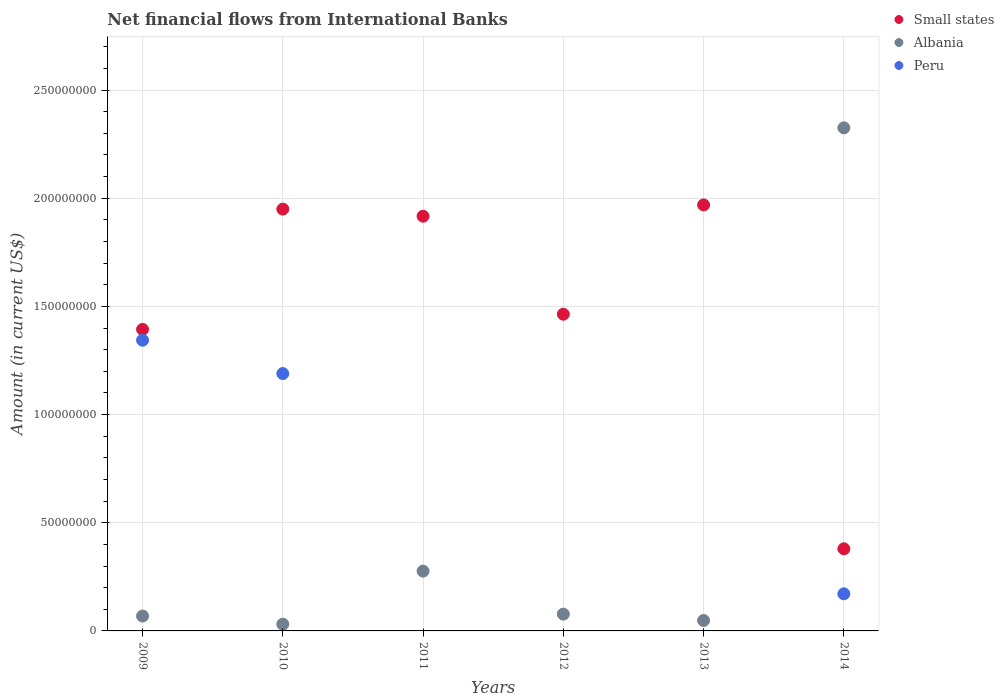How many different coloured dotlines are there?
Offer a terse response. 3. Is the number of dotlines equal to the number of legend labels?
Ensure brevity in your answer.  No. What is the net financial aid flows in Albania in 2014?
Keep it short and to the point. 2.33e+08. Across all years, what is the maximum net financial aid flows in Albania?
Offer a terse response. 2.33e+08. Across all years, what is the minimum net financial aid flows in Small states?
Give a very brief answer. 3.80e+07. In which year was the net financial aid flows in Albania maximum?
Your answer should be very brief. 2014. What is the total net financial aid flows in Peru in the graph?
Offer a very short reply. 2.70e+08. What is the difference between the net financial aid flows in Albania in 2009 and that in 2010?
Offer a terse response. 3.77e+06. What is the difference between the net financial aid flows in Small states in 2011 and the net financial aid flows in Peru in 2010?
Provide a succinct answer. 7.27e+07. What is the average net financial aid flows in Albania per year?
Your answer should be very brief. 4.71e+07. In the year 2014, what is the difference between the net financial aid flows in Small states and net financial aid flows in Peru?
Ensure brevity in your answer.  2.08e+07. What is the ratio of the net financial aid flows in Small states in 2010 to that in 2013?
Make the answer very short. 0.99. Is the net financial aid flows in Albania in 2012 less than that in 2013?
Keep it short and to the point. No. Is the difference between the net financial aid flows in Small states in 2010 and 2014 greater than the difference between the net financial aid flows in Peru in 2010 and 2014?
Your answer should be compact. Yes. What is the difference between the highest and the second highest net financial aid flows in Small states?
Provide a succinct answer. 1.94e+06. What is the difference between the highest and the lowest net financial aid flows in Small states?
Make the answer very short. 1.59e+08. Is it the case that in every year, the sum of the net financial aid flows in Peru and net financial aid flows in Small states  is greater than the net financial aid flows in Albania?
Give a very brief answer. No. Does the net financial aid flows in Albania monotonically increase over the years?
Give a very brief answer. No. Is the net financial aid flows in Albania strictly greater than the net financial aid flows in Small states over the years?
Your answer should be compact. No. Is the net financial aid flows in Small states strictly less than the net financial aid flows in Albania over the years?
Your answer should be very brief. No. What is the difference between two consecutive major ticks on the Y-axis?
Keep it short and to the point. 5.00e+07. Are the values on the major ticks of Y-axis written in scientific E-notation?
Make the answer very short. No. What is the title of the graph?
Ensure brevity in your answer.  Net financial flows from International Banks. Does "Hong Kong" appear as one of the legend labels in the graph?
Make the answer very short. No. What is the label or title of the Y-axis?
Make the answer very short. Amount (in current US$). What is the Amount (in current US$) in Small states in 2009?
Make the answer very short. 1.39e+08. What is the Amount (in current US$) in Albania in 2009?
Make the answer very short. 6.87e+06. What is the Amount (in current US$) in Peru in 2009?
Your answer should be compact. 1.34e+08. What is the Amount (in current US$) of Small states in 2010?
Your answer should be very brief. 1.95e+08. What is the Amount (in current US$) of Albania in 2010?
Your answer should be very brief. 3.11e+06. What is the Amount (in current US$) in Peru in 2010?
Ensure brevity in your answer.  1.19e+08. What is the Amount (in current US$) in Small states in 2011?
Give a very brief answer. 1.92e+08. What is the Amount (in current US$) of Albania in 2011?
Ensure brevity in your answer.  2.76e+07. What is the Amount (in current US$) in Peru in 2011?
Provide a short and direct response. 0. What is the Amount (in current US$) of Small states in 2012?
Your answer should be compact. 1.46e+08. What is the Amount (in current US$) of Albania in 2012?
Your response must be concise. 7.76e+06. What is the Amount (in current US$) of Peru in 2012?
Ensure brevity in your answer.  0. What is the Amount (in current US$) of Small states in 2013?
Provide a succinct answer. 1.97e+08. What is the Amount (in current US$) in Albania in 2013?
Offer a very short reply. 4.83e+06. What is the Amount (in current US$) of Small states in 2014?
Make the answer very short. 3.80e+07. What is the Amount (in current US$) of Albania in 2014?
Make the answer very short. 2.33e+08. What is the Amount (in current US$) in Peru in 2014?
Make the answer very short. 1.72e+07. Across all years, what is the maximum Amount (in current US$) of Small states?
Your answer should be very brief. 1.97e+08. Across all years, what is the maximum Amount (in current US$) in Albania?
Make the answer very short. 2.33e+08. Across all years, what is the maximum Amount (in current US$) in Peru?
Make the answer very short. 1.34e+08. Across all years, what is the minimum Amount (in current US$) of Small states?
Provide a short and direct response. 3.80e+07. Across all years, what is the minimum Amount (in current US$) of Albania?
Offer a terse response. 3.11e+06. What is the total Amount (in current US$) in Small states in the graph?
Your answer should be compact. 9.07e+08. What is the total Amount (in current US$) in Albania in the graph?
Ensure brevity in your answer.  2.83e+08. What is the total Amount (in current US$) in Peru in the graph?
Your answer should be compact. 2.70e+08. What is the difference between the Amount (in current US$) in Small states in 2009 and that in 2010?
Your response must be concise. -5.56e+07. What is the difference between the Amount (in current US$) of Albania in 2009 and that in 2010?
Keep it short and to the point. 3.77e+06. What is the difference between the Amount (in current US$) in Peru in 2009 and that in 2010?
Keep it short and to the point. 1.54e+07. What is the difference between the Amount (in current US$) of Small states in 2009 and that in 2011?
Give a very brief answer. -5.23e+07. What is the difference between the Amount (in current US$) in Albania in 2009 and that in 2011?
Your answer should be compact. -2.08e+07. What is the difference between the Amount (in current US$) in Small states in 2009 and that in 2012?
Provide a succinct answer. -7.02e+06. What is the difference between the Amount (in current US$) of Albania in 2009 and that in 2012?
Ensure brevity in your answer.  -8.86e+05. What is the difference between the Amount (in current US$) of Small states in 2009 and that in 2013?
Provide a short and direct response. -5.75e+07. What is the difference between the Amount (in current US$) of Albania in 2009 and that in 2013?
Provide a succinct answer. 2.05e+06. What is the difference between the Amount (in current US$) in Small states in 2009 and that in 2014?
Ensure brevity in your answer.  1.01e+08. What is the difference between the Amount (in current US$) of Albania in 2009 and that in 2014?
Your answer should be very brief. -2.26e+08. What is the difference between the Amount (in current US$) in Peru in 2009 and that in 2014?
Provide a short and direct response. 1.17e+08. What is the difference between the Amount (in current US$) in Small states in 2010 and that in 2011?
Offer a terse response. 3.28e+06. What is the difference between the Amount (in current US$) in Albania in 2010 and that in 2011?
Your response must be concise. -2.45e+07. What is the difference between the Amount (in current US$) of Small states in 2010 and that in 2012?
Offer a very short reply. 4.86e+07. What is the difference between the Amount (in current US$) in Albania in 2010 and that in 2012?
Keep it short and to the point. -4.65e+06. What is the difference between the Amount (in current US$) of Small states in 2010 and that in 2013?
Give a very brief answer. -1.94e+06. What is the difference between the Amount (in current US$) in Albania in 2010 and that in 2013?
Your answer should be compact. -1.72e+06. What is the difference between the Amount (in current US$) in Small states in 2010 and that in 2014?
Your answer should be compact. 1.57e+08. What is the difference between the Amount (in current US$) in Albania in 2010 and that in 2014?
Give a very brief answer. -2.29e+08. What is the difference between the Amount (in current US$) in Peru in 2010 and that in 2014?
Ensure brevity in your answer.  1.02e+08. What is the difference between the Amount (in current US$) in Small states in 2011 and that in 2012?
Your answer should be compact. 4.53e+07. What is the difference between the Amount (in current US$) in Albania in 2011 and that in 2012?
Your answer should be compact. 1.99e+07. What is the difference between the Amount (in current US$) in Small states in 2011 and that in 2013?
Ensure brevity in your answer.  -5.22e+06. What is the difference between the Amount (in current US$) in Albania in 2011 and that in 2013?
Your response must be concise. 2.28e+07. What is the difference between the Amount (in current US$) in Small states in 2011 and that in 2014?
Ensure brevity in your answer.  1.54e+08. What is the difference between the Amount (in current US$) of Albania in 2011 and that in 2014?
Provide a short and direct response. -2.05e+08. What is the difference between the Amount (in current US$) of Small states in 2012 and that in 2013?
Offer a terse response. -5.05e+07. What is the difference between the Amount (in current US$) in Albania in 2012 and that in 2013?
Ensure brevity in your answer.  2.93e+06. What is the difference between the Amount (in current US$) in Small states in 2012 and that in 2014?
Ensure brevity in your answer.  1.08e+08. What is the difference between the Amount (in current US$) in Albania in 2012 and that in 2014?
Give a very brief answer. -2.25e+08. What is the difference between the Amount (in current US$) of Small states in 2013 and that in 2014?
Your answer should be very brief. 1.59e+08. What is the difference between the Amount (in current US$) in Albania in 2013 and that in 2014?
Offer a terse response. -2.28e+08. What is the difference between the Amount (in current US$) in Small states in 2009 and the Amount (in current US$) in Albania in 2010?
Keep it short and to the point. 1.36e+08. What is the difference between the Amount (in current US$) in Small states in 2009 and the Amount (in current US$) in Peru in 2010?
Give a very brief answer. 2.04e+07. What is the difference between the Amount (in current US$) of Albania in 2009 and the Amount (in current US$) of Peru in 2010?
Give a very brief answer. -1.12e+08. What is the difference between the Amount (in current US$) in Small states in 2009 and the Amount (in current US$) in Albania in 2011?
Your answer should be very brief. 1.12e+08. What is the difference between the Amount (in current US$) in Small states in 2009 and the Amount (in current US$) in Albania in 2012?
Give a very brief answer. 1.32e+08. What is the difference between the Amount (in current US$) of Small states in 2009 and the Amount (in current US$) of Albania in 2013?
Your response must be concise. 1.35e+08. What is the difference between the Amount (in current US$) of Small states in 2009 and the Amount (in current US$) of Albania in 2014?
Offer a terse response. -9.32e+07. What is the difference between the Amount (in current US$) in Small states in 2009 and the Amount (in current US$) in Peru in 2014?
Your response must be concise. 1.22e+08. What is the difference between the Amount (in current US$) of Albania in 2009 and the Amount (in current US$) of Peru in 2014?
Your response must be concise. -1.03e+07. What is the difference between the Amount (in current US$) of Small states in 2010 and the Amount (in current US$) of Albania in 2011?
Provide a succinct answer. 1.67e+08. What is the difference between the Amount (in current US$) in Small states in 2010 and the Amount (in current US$) in Albania in 2012?
Your answer should be compact. 1.87e+08. What is the difference between the Amount (in current US$) of Small states in 2010 and the Amount (in current US$) of Albania in 2013?
Give a very brief answer. 1.90e+08. What is the difference between the Amount (in current US$) in Small states in 2010 and the Amount (in current US$) in Albania in 2014?
Give a very brief answer. -3.76e+07. What is the difference between the Amount (in current US$) of Small states in 2010 and the Amount (in current US$) of Peru in 2014?
Offer a very short reply. 1.78e+08. What is the difference between the Amount (in current US$) of Albania in 2010 and the Amount (in current US$) of Peru in 2014?
Your answer should be very brief. -1.40e+07. What is the difference between the Amount (in current US$) of Small states in 2011 and the Amount (in current US$) of Albania in 2012?
Keep it short and to the point. 1.84e+08. What is the difference between the Amount (in current US$) of Small states in 2011 and the Amount (in current US$) of Albania in 2013?
Provide a succinct answer. 1.87e+08. What is the difference between the Amount (in current US$) of Small states in 2011 and the Amount (in current US$) of Albania in 2014?
Make the answer very short. -4.08e+07. What is the difference between the Amount (in current US$) of Small states in 2011 and the Amount (in current US$) of Peru in 2014?
Your answer should be compact. 1.75e+08. What is the difference between the Amount (in current US$) of Albania in 2011 and the Amount (in current US$) of Peru in 2014?
Keep it short and to the point. 1.05e+07. What is the difference between the Amount (in current US$) in Small states in 2012 and the Amount (in current US$) in Albania in 2013?
Offer a terse response. 1.42e+08. What is the difference between the Amount (in current US$) in Small states in 2012 and the Amount (in current US$) in Albania in 2014?
Provide a succinct answer. -8.61e+07. What is the difference between the Amount (in current US$) of Small states in 2012 and the Amount (in current US$) of Peru in 2014?
Ensure brevity in your answer.  1.29e+08. What is the difference between the Amount (in current US$) in Albania in 2012 and the Amount (in current US$) in Peru in 2014?
Give a very brief answer. -9.39e+06. What is the difference between the Amount (in current US$) of Small states in 2013 and the Amount (in current US$) of Albania in 2014?
Your answer should be very brief. -3.56e+07. What is the difference between the Amount (in current US$) of Small states in 2013 and the Amount (in current US$) of Peru in 2014?
Ensure brevity in your answer.  1.80e+08. What is the difference between the Amount (in current US$) in Albania in 2013 and the Amount (in current US$) in Peru in 2014?
Offer a very short reply. -1.23e+07. What is the average Amount (in current US$) of Small states per year?
Your response must be concise. 1.51e+08. What is the average Amount (in current US$) in Albania per year?
Keep it short and to the point. 4.71e+07. What is the average Amount (in current US$) of Peru per year?
Your response must be concise. 4.51e+07. In the year 2009, what is the difference between the Amount (in current US$) in Small states and Amount (in current US$) in Albania?
Make the answer very short. 1.32e+08. In the year 2009, what is the difference between the Amount (in current US$) in Small states and Amount (in current US$) in Peru?
Your response must be concise. 4.99e+06. In the year 2009, what is the difference between the Amount (in current US$) of Albania and Amount (in current US$) of Peru?
Ensure brevity in your answer.  -1.27e+08. In the year 2010, what is the difference between the Amount (in current US$) in Small states and Amount (in current US$) in Albania?
Ensure brevity in your answer.  1.92e+08. In the year 2010, what is the difference between the Amount (in current US$) in Small states and Amount (in current US$) in Peru?
Your answer should be very brief. 7.60e+07. In the year 2010, what is the difference between the Amount (in current US$) of Albania and Amount (in current US$) of Peru?
Provide a short and direct response. -1.16e+08. In the year 2011, what is the difference between the Amount (in current US$) of Small states and Amount (in current US$) of Albania?
Give a very brief answer. 1.64e+08. In the year 2012, what is the difference between the Amount (in current US$) in Small states and Amount (in current US$) in Albania?
Make the answer very short. 1.39e+08. In the year 2013, what is the difference between the Amount (in current US$) of Small states and Amount (in current US$) of Albania?
Your answer should be compact. 1.92e+08. In the year 2014, what is the difference between the Amount (in current US$) of Small states and Amount (in current US$) of Albania?
Your response must be concise. -1.95e+08. In the year 2014, what is the difference between the Amount (in current US$) in Small states and Amount (in current US$) in Peru?
Your answer should be compact. 2.08e+07. In the year 2014, what is the difference between the Amount (in current US$) in Albania and Amount (in current US$) in Peru?
Your answer should be very brief. 2.15e+08. What is the ratio of the Amount (in current US$) in Small states in 2009 to that in 2010?
Your answer should be very brief. 0.71. What is the ratio of the Amount (in current US$) in Albania in 2009 to that in 2010?
Give a very brief answer. 2.21. What is the ratio of the Amount (in current US$) in Peru in 2009 to that in 2010?
Provide a short and direct response. 1.13. What is the ratio of the Amount (in current US$) of Small states in 2009 to that in 2011?
Make the answer very short. 0.73. What is the ratio of the Amount (in current US$) in Albania in 2009 to that in 2011?
Offer a terse response. 0.25. What is the ratio of the Amount (in current US$) in Small states in 2009 to that in 2012?
Provide a short and direct response. 0.95. What is the ratio of the Amount (in current US$) of Albania in 2009 to that in 2012?
Ensure brevity in your answer.  0.89. What is the ratio of the Amount (in current US$) of Small states in 2009 to that in 2013?
Make the answer very short. 0.71. What is the ratio of the Amount (in current US$) of Albania in 2009 to that in 2013?
Offer a very short reply. 1.42. What is the ratio of the Amount (in current US$) in Small states in 2009 to that in 2014?
Give a very brief answer. 3.67. What is the ratio of the Amount (in current US$) of Albania in 2009 to that in 2014?
Your answer should be very brief. 0.03. What is the ratio of the Amount (in current US$) in Peru in 2009 to that in 2014?
Give a very brief answer. 7.83. What is the ratio of the Amount (in current US$) in Small states in 2010 to that in 2011?
Provide a short and direct response. 1.02. What is the ratio of the Amount (in current US$) of Albania in 2010 to that in 2011?
Your answer should be very brief. 0.11. What is the ratio of the Amount (in current US$) in Small states in 2010 to that in 2012?
Give a very brief answer. 1.33. What is the ratio of the Amount (in current US$) of Albania in 2010 to that in 2012?
Offer a very short reply. 0.4. What is the ratio of the Amount (in current US$) in Small states in 2010 to that in 2013?
Your answer should be very brief. 0.99. What is the ratio of the Amount (in current US$) of Albania in 2010 to that in 2013?
Your answer should be compact. 0.64. What is the ratio of the Amount (in current US$) of Small states in 2010 to that in 2014?
Provide a succinct answer. 5.14. What is the ratio of the Amount (in current US$) in Albania in 2010 to that in 2014?
Keep it short and to the point. 0.01. What is the ratio of the Amount (in current US$) of Peru in 2010 to that in 2014?
Make the answer very short. 6.94. What is the ratio of the Amount (in current US$) in Small states in 2011 to that in 2012?
Keep it short and to the point. 1.31. What is the ratio of the Amount (in current US$) in Albania in 2011 to that in 2012?
Provide a short and direct response. 3.56. What is the ratio of the Amount (in current US$) of Small states in 2011 to that in 2013?
Provide a short and direct response. 0.97. What is the ratio of the Amount (in current US$) in Albania in 2011 to that in 2013?
Keep it short and to the point. 5.73. What is the ratio of the Amount (in current US$) of Small states in 2011 to that in 2014?
Your answer should be compact. 5.05. What is the ratio of the Amount (in current US$) of Albania in 2011 to that in 2014?
Your answer should be very brief. 0.12. What is the ratio of the Amount (in current US$) in Small states in 2012 to that in 2013?
Provide a succinct answer. 0.74. What is the ratio of the Amount (in current US$) of Albania in 2012 to that in 2013?
Your answer should be compact. 1.61. What is the ratio of the Amount (in current US$) of Small states in 2012 to that in 2014?
Provide a short and direct response. 3.86. What is the ratio of the Amount (in current US$) in Albania in 2012 to that in 2014?
Make the answer very short. 0.03. What is the ratio of the Amount (in current US$) in Small states in 2013 to that in 2014?
Your answer should be very brief. 5.19. What is the ratio of the Amount (in current US$) of Albania in 2013 to that in 2014?
Your answer should be compact. 0.02. What is the difference between the highest and the second highest Amount (in current US$) in Small states?
Offer a terse response. 1.94e+06. What is the difference between the highest and the second highest Amount (in current US$) of Albania?
Provide a succinct answer. 2.05e+08. What is the difference between the highest and the second highest Amount (in current US$) in Peru?
Provide a short and direct response. 1.54e+07. What is the difference between the highest and the lowest Amount (in current US$) in Small states?
Provide a short and direct response. 1.59e+08. What is the difference between the highest and the lowest Amount (in current US$) of Albania?
Give a very brief answer. 2.29e+08. What is the difference between the highest and the lowest Amount (in current US$) of Peru?
Your answer should be compact. 1.34e+08. 